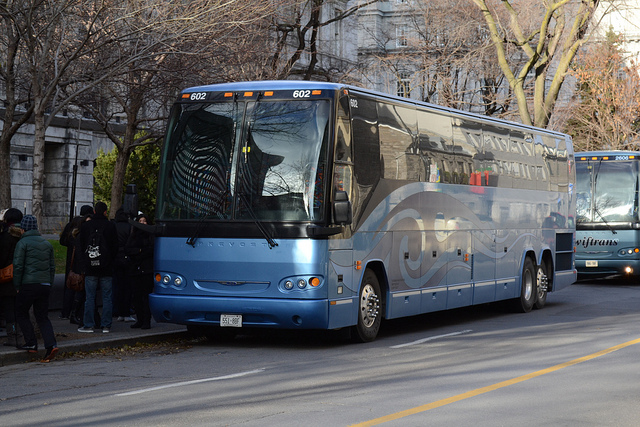How many people are there? Based on the reflections and visible areas through the windows of the bus, there appear to be approximately 5 people. However, due to limited visibility, there could be more individuals inside that are not immediately observable from this angle. 